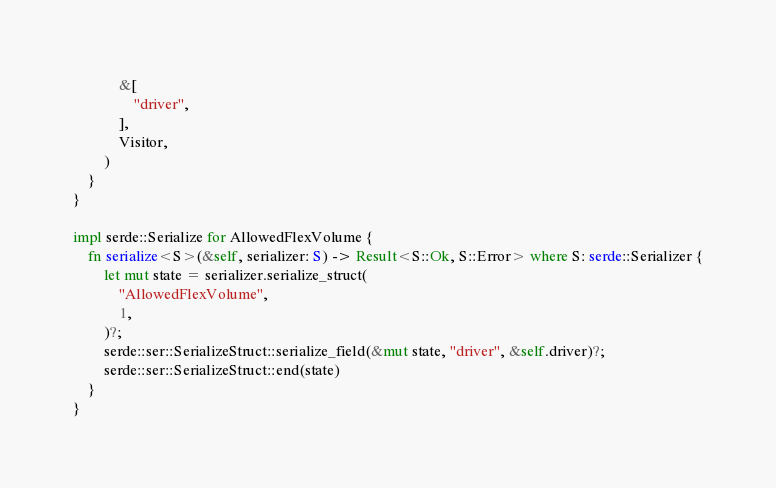<code> <loc_0><loc_0><loc_500><loc_500><_Rust_>            &[
                "driver",
            ],
            Visitor,
        )
    }
}

impl serde::Serialize for AllowedFlexVolume {
    fn serialize<S>(&self, serializer: S) -> Result<S::Ok, S::Error> where S: serde::Serializer {
        let mut state = serializer.serialize_struct(
            "AllowedFlexVolume",
            1,
        )?;
        serde::ser::SerializeStruct::serialize_field(&mut state, "driver", &self.driver)?;
        serde::ser::SerializeStruct::end(state)
    }
}
</code> 